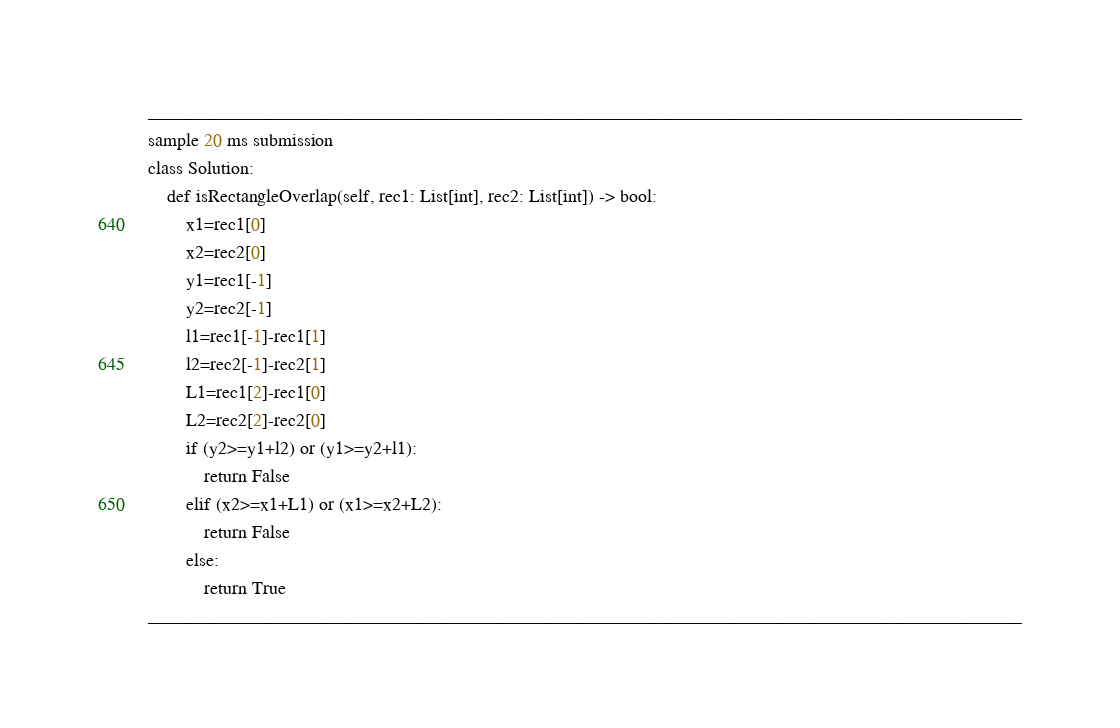<code> <loc_0><loc_0><loc_500><loc_500><_Python_>__________________________________________________________________________________________________
sample 20 ms submission
class Solution:
    def isRectangleOverlap(self, rec1: List[int], rec2: List[int]) -> bool:
        x1=rec1[0]
        x2=rec2[0]
        y1=rec1[-1]
        y2=rec2[-1]
        l1=rec1[-1]-rec1[1]
        l2=rec2[-1]-rec2[1]
        L1=rec1[2]-rec1[0]
        L2=rec2[2]-rec2[0]
        if (y2>=y1+l2) or (y1>=y2+l1):
            return False
        elif (x2>=x1+L1) or (x1>=x2+L2):
            return False
        else:
            return True 
__________________________________________________________________________________________________</code> 